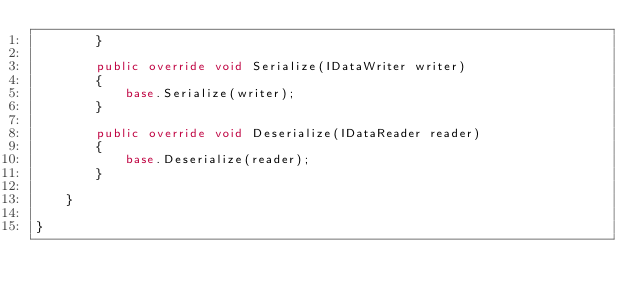<code> <loc_0><loc_0><loc_500><loc_500><_C#_>        }
        
        public override void Serialize(IDataWriter writer)
        {
            base.Serialize(writer);
        }
        
        public override void Deserialize(IDataReader reader)
        {
            base.Deserialize(reader);
        }
        
    }
    
}</code> 